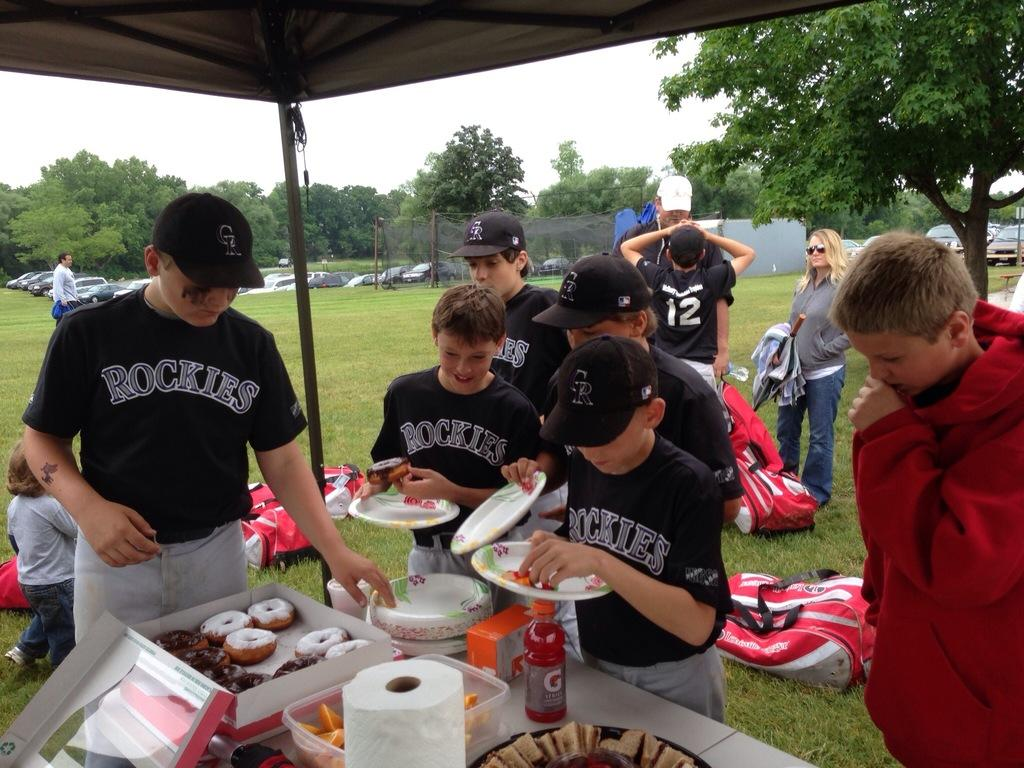<image>
Summarize the visual content of the image. Several boys in Rockies uniforms gather at a table of food. 